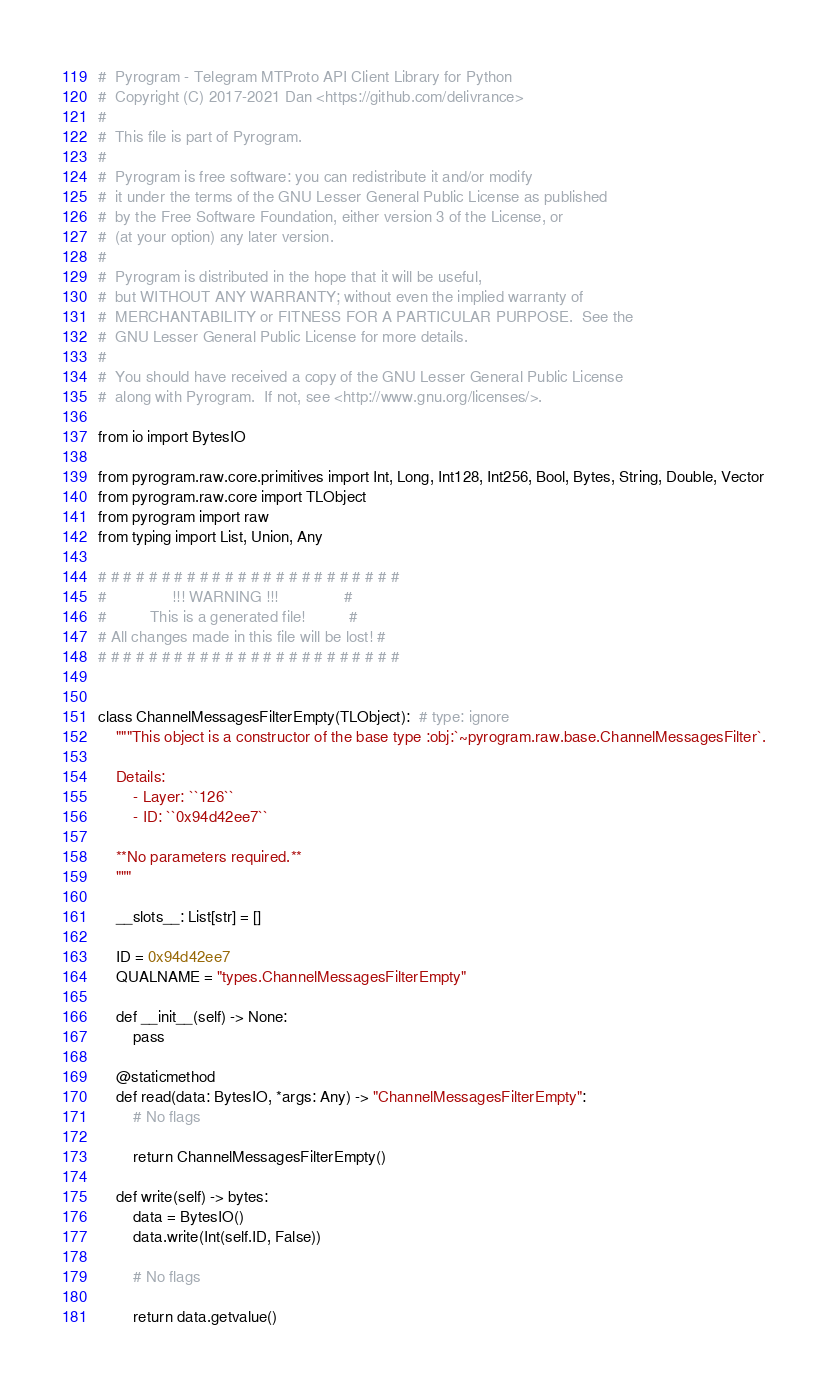Convert code to text. <code><loc_0><loc_0><loc_500><loc_500><_Python_>#  Pyrogram - Telegram MTProto API Client Library for Python
#  Copyright (C) 2017-2021 Dan <https://github.com/delivrance>
#
#  This file is part of Pyrogram.
#
#  Pyrogram is free software: you can redistribute it and/or modify
#  it under the terms of the GNU Lesser General Public License as published
#  by the Free Software Foundation, either version 3 of the License, or
#  (at your option) any later version.
#
#  Pyrogram is distributed in the hope that it will be useful,
#  but WITHOUT ANY WARRANTY; without even the implied warranty of
#  MERCHANTABILITY or FITNESS FOR A PARTICULAR PURPOSE.  See the
#  GNU Lesser General Public License for more details.
#
#  You should have received a copy of the GNU Lesser General Public License
#  along with Pyrogram.  If not, see <http://www.gnu.org/licenses/>.

from io import BytesIO

from pyrogram.raw.core.primitives import Int, Long, Int128, Int256, Bool, Bytes, String, Double, Vector
from pyrogram.raw.core import TLObject
from pyrogram import raw
from typing import List, Union, Any

# # # # # # # # # # # # # # # # # # # # # # # #
#               !!! WARNING !!!               #
#          This is a generated file!          #
# All changes made in this file will be lost! #
# # # # # # # # # # # # # # # # # # # # # # # #


class ChannelMessagesFilterEmpty(TLObject):  # type: ignore
    """This object is a constructor of the base type :obj:`~pyrogram.raw.base.ChannelMessagesFilter`.

    Details:
        - Layer: ``126``
        - ID: ``0x94d42ee7``

    **No parameters required.**
    """

    __slots__: List[str] = []

    ID = 0x94d42ee7
    QUALNAME = "types.ChannelMessagesFilterEmpty"

    def __init__(self) -> None:
        pass

    @staticmethod
    def read(data: BytesIO, *args: Any) -> "ChannelMessagesFilterEmpty":
        # No flags
        
        return ChannelMessagesFilterEmpty()

    def write(self) -> bytes:
        data = BytesIO()
        data.write(Int(self.ID, False))

        # No flags
        
        return data.getvalue()
</code> 